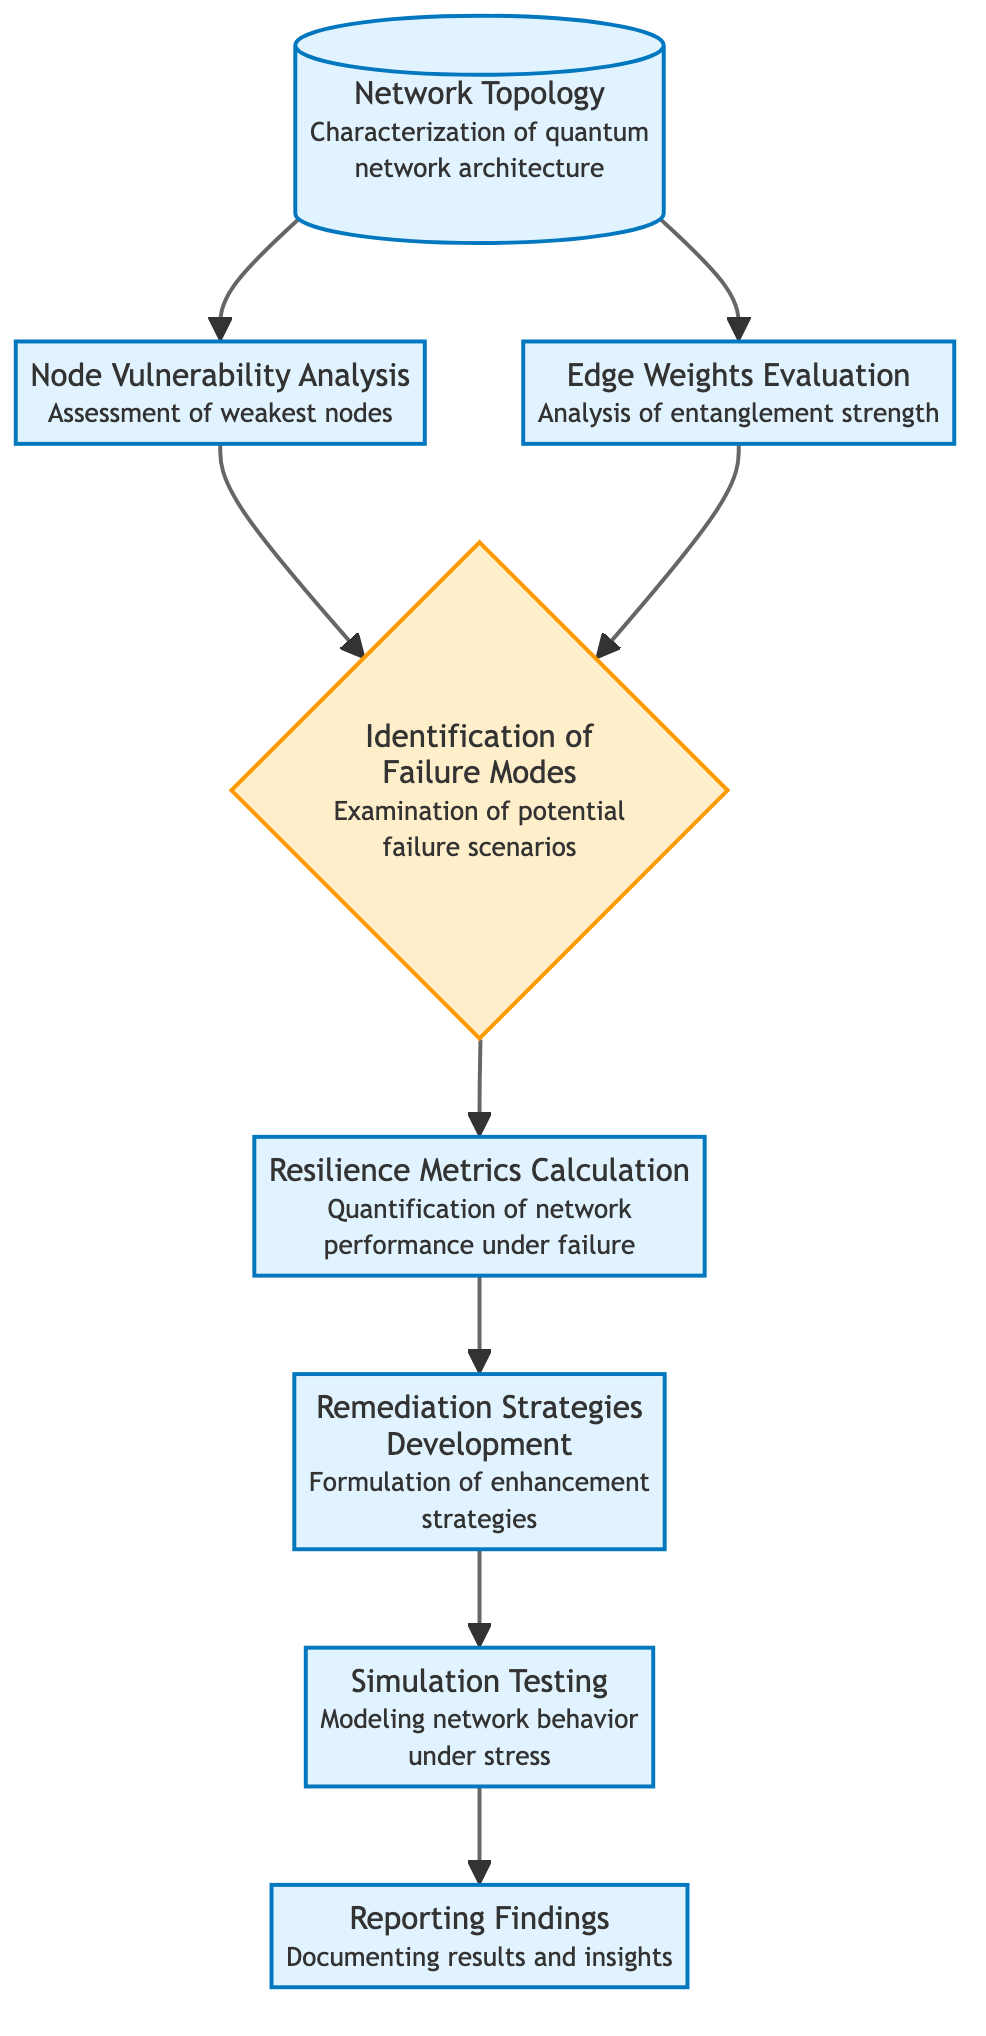What is the first step in analyzing quantum network resilience? The first step is "Network Topology," which characterizes the quantum network architecture and its components.
Answer: Network Topology How many main processes are involved in the flow chart? There are six main processes: Network Topology, Node Vulnerability Analysis, Edge Weights Evaluation, Resilience Metrics Calculation, Remediation Strategies Development, and Reporting Findings.
Answer: Six What type of analysis follows Node Vulnerability Analysis? After Node Vulnerability Analysis, the next step is "Identification of Failure Modes," which examines potential failure scenarios within the quantum network.
Answer: Identification of Failure Modes Which component evaluates the strength of entanglement between qubits? The component responsible for evaluating the strength of entanglement between qubits is "Edge Weights Evaluation."
Answer: Edge Weights Evaluation What is the purpose of "Simulation Testing"? The purpose of "Simulation Testing" is to model network behavior under stress and analyze the outcomes.
Answer: Model network behavior under stress What is the final step in this analysis process? The final step is "Reporting Findings," which involves documenting results and insights on network resilience.
Answer: Reporting Findings How does Node Vulnerability Analysis affect the identification of failure modes? Node Vulnerability Analysis informs the "Identification of Failure Modes" by assessing the weakest nodes and their impact on connectivity, leading to a better understanding of failure scenarios.
Answer: Informs identification of failure modes What leads to the development of remediation strategies? "Resilience Metrics Calculation" quantifies the network's ability to maintain performance under failure, which leads to the formulation of "Remediation Strategies Development" to enhance resilience.
Answer: Resilience Metrics Calculation What process follows the identification of failure modes? Following the "Identification of Failure Modes," the process is "Resilience Metrics Calculation," which quantifies network performance under potential failures.
Answer: Resilience Metrics Calculation 